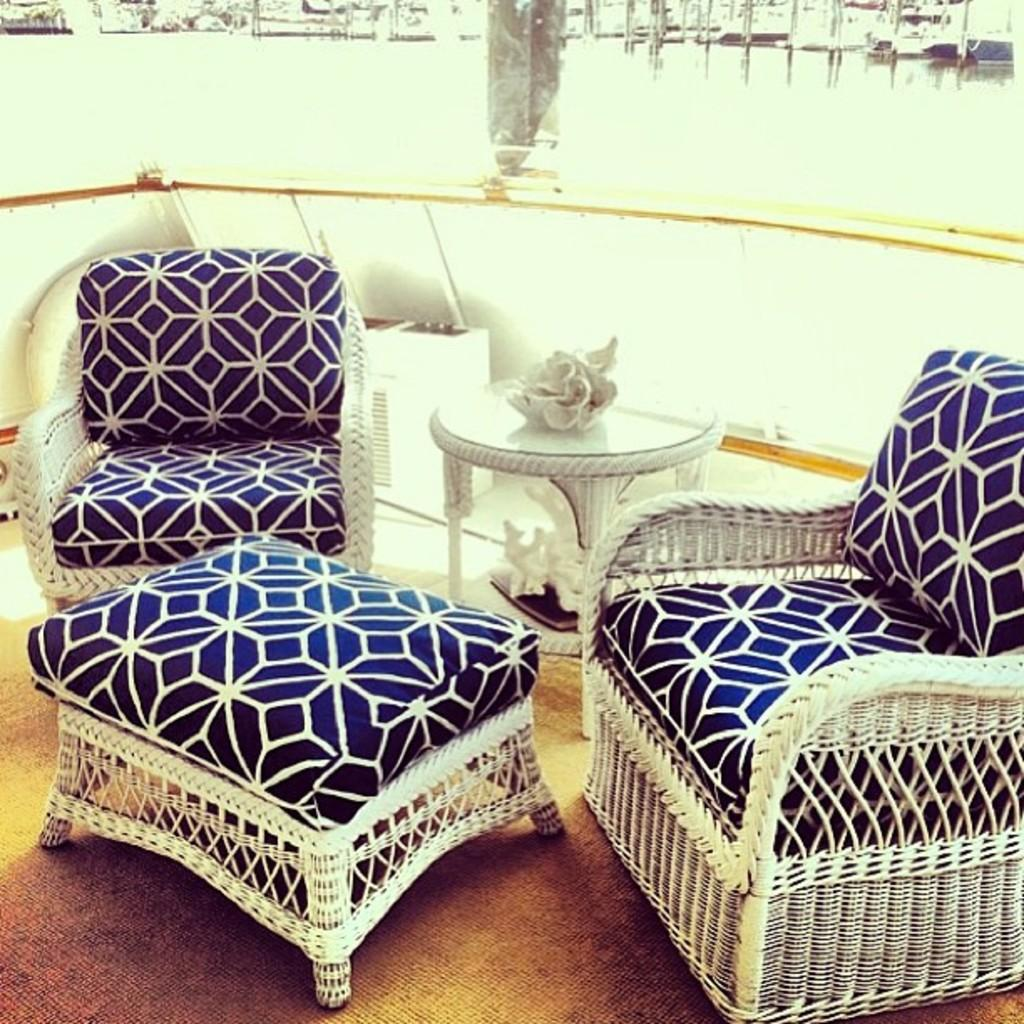What type of furniture is visible in the image? There are chairs and tables in the image. Can you describe the objects on the floor in the image? There are some objects on the floor in the image. What type of prison is visible in the image? There is no prison present in the image. How does the image look from a different angle? The image cannot be viewed from a different angle, as it is a static image. 